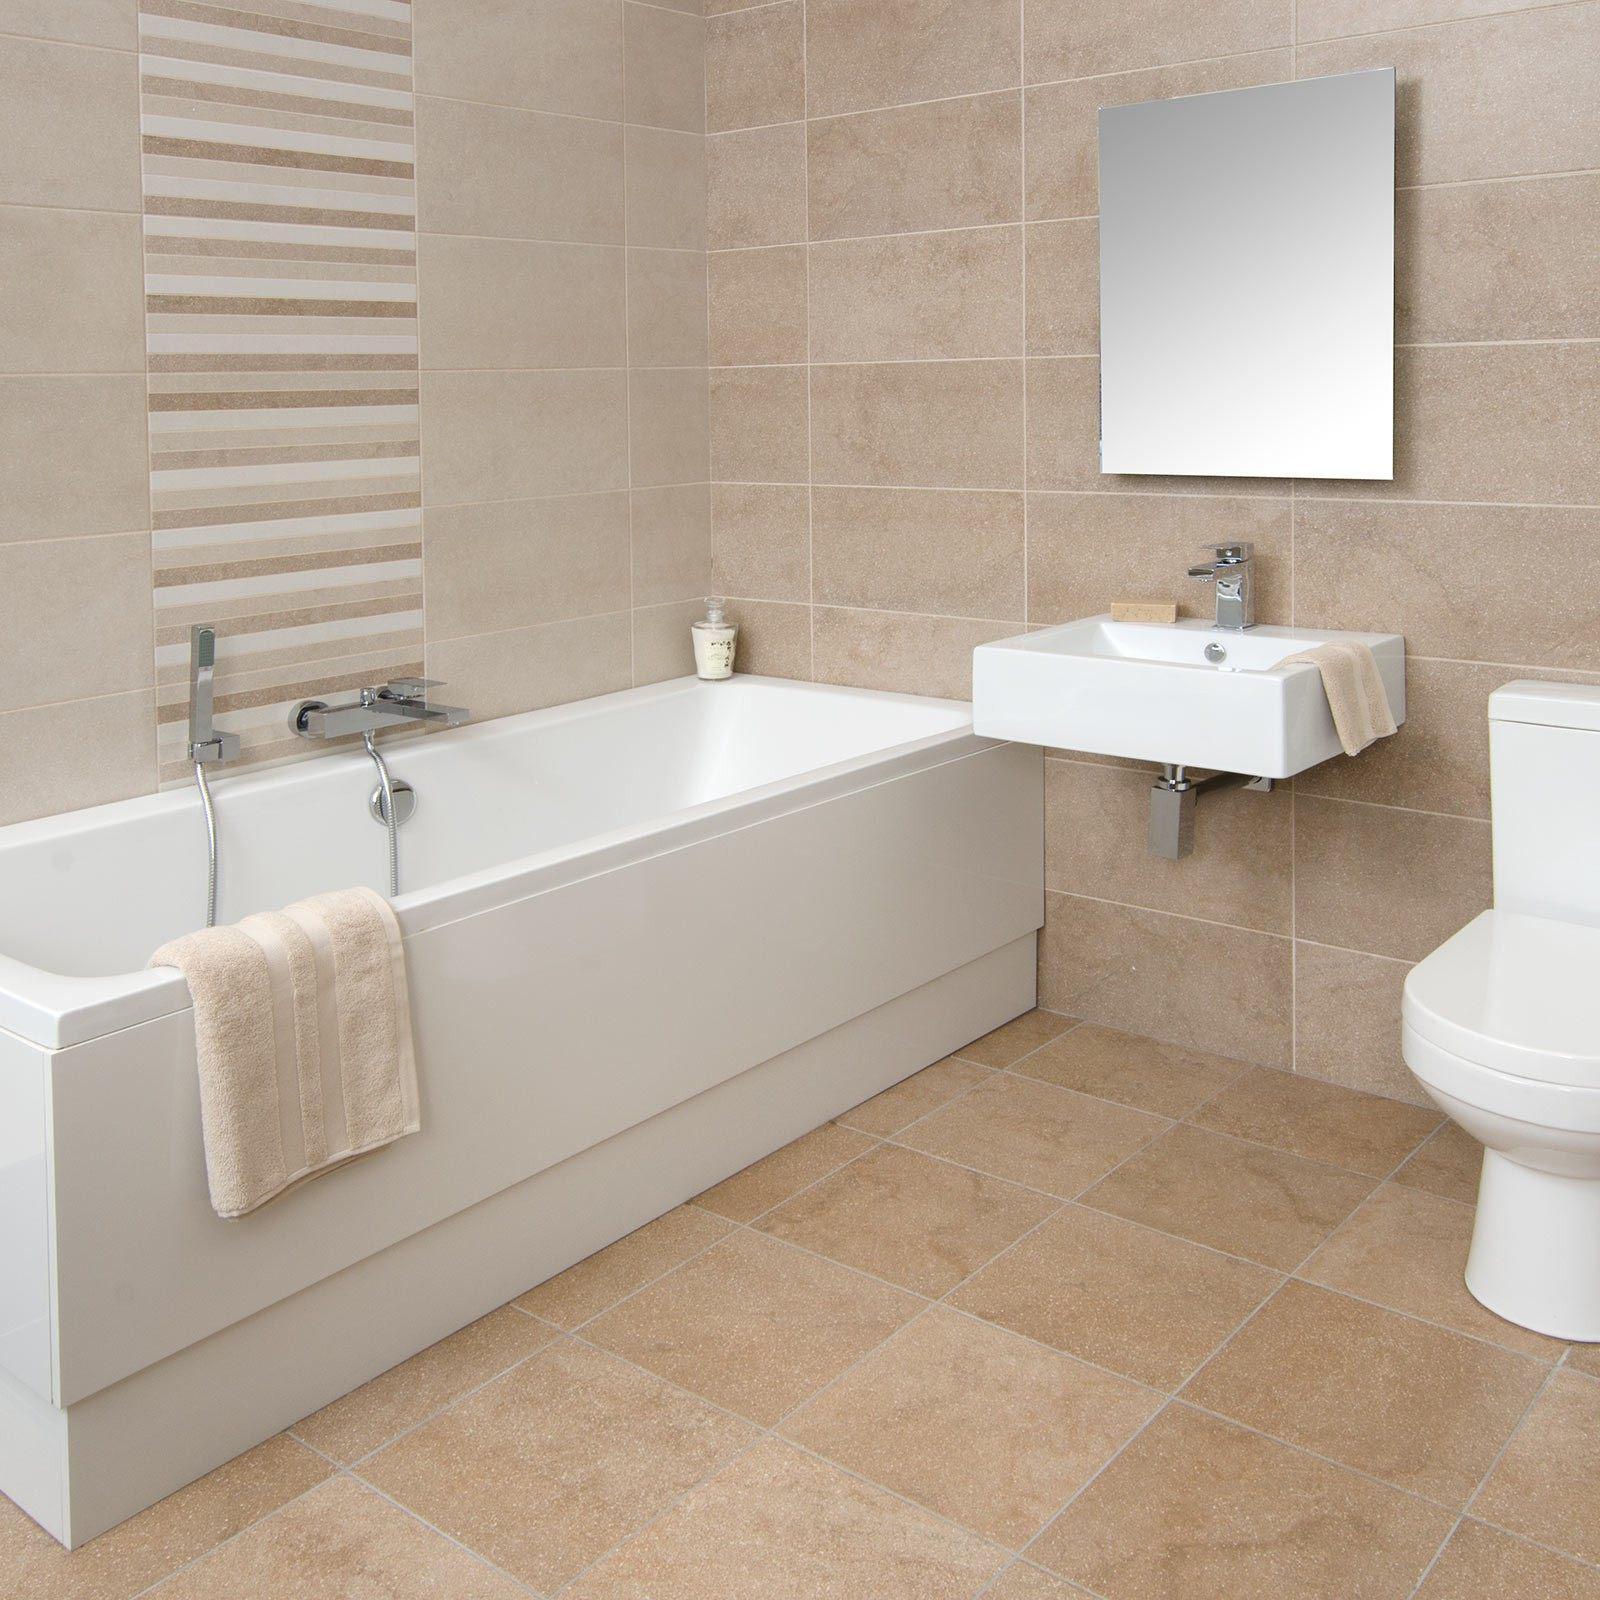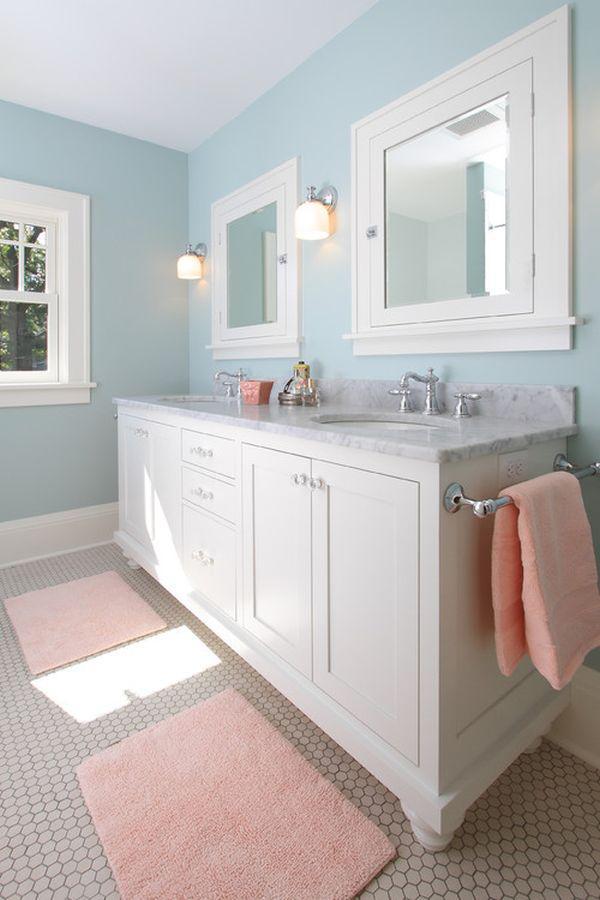The first image is the image on the left, the second image is the image on the right. For the images displayed, is the sentence "An image features a room with solid-white walls, and a shower curtain featuring a turquoise lower half around an all-white tub." factually correct? Answer yes or no. No. The first image is the image on the left, the second image is the image on the right. Examine the images to the left and right. Is the description "At least one bathroom has a stepstool." accurate? Answer yes or no. No. 